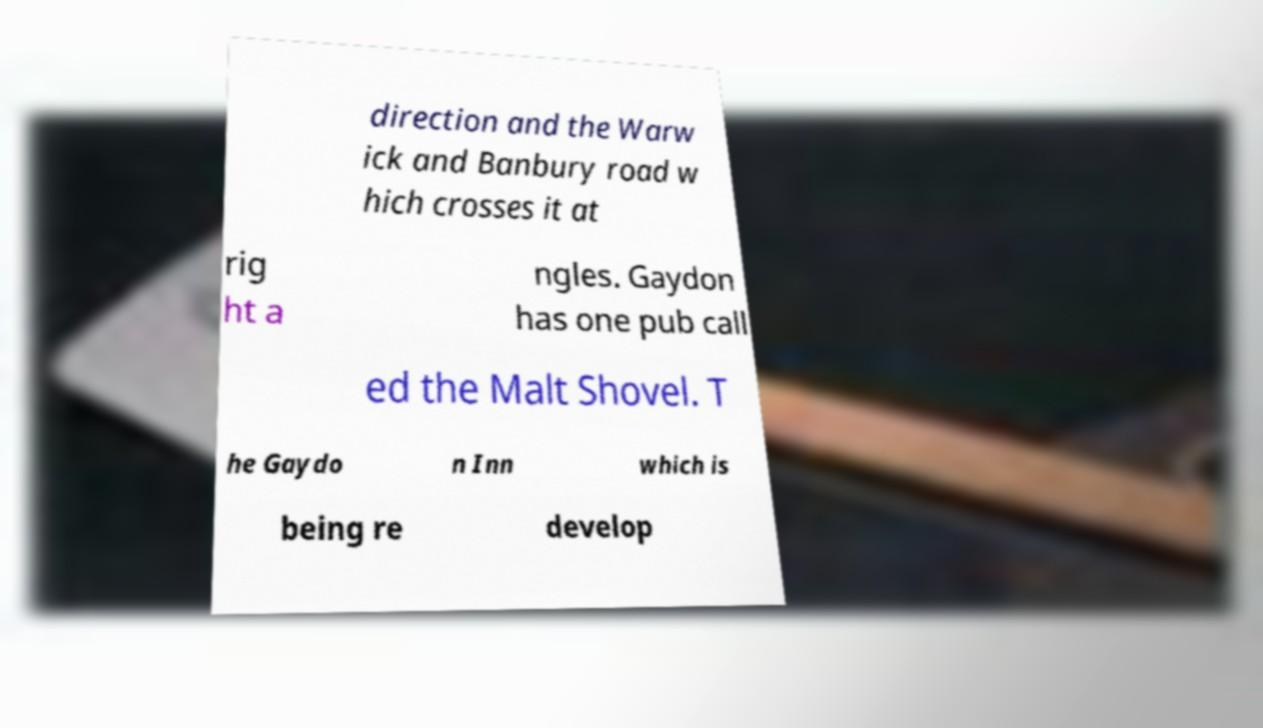I need the written content from this picture converted into text. Can you do that? direction and the Warw ick and Banbury road w hich crosses it at rig ht a ngles. Gaydon has one pub call ed the Malt Shovel. T he Gaydo n Inn which is being re develop 